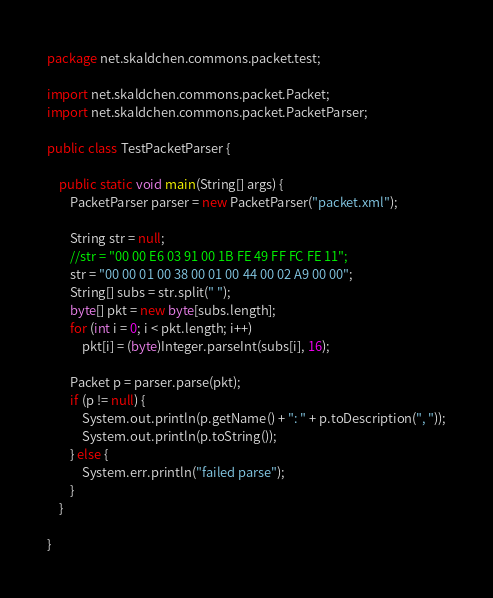<code> <loc_0><loc_0><loc_500><loc_500><_Java_>package net.skaldchen.commons.packet.test;

import net.skaldchen.commons.packet.Packet;
import net.skaldchen.commons.packet.PacketParser;

public class TestPacketParser {

    public static void main(String[] args) {
        PacketParser parser = new PacketParser("packet.xml");

        String str = null;
        //str = "00 00 E6 03 91 00 1B FE 49 FF FC FE 11";
        str = "00 00 01 00 38 00 01 00 44 00 02 A9 00 00";
        String[] subs = str.split(" ");
        byte[] pkt = new byte[subs.length];
        for (int i = 0; i < pkt.length; i++)
            pkt[i] = (byte)Integer.parseInt(subs[i], 16);

        Packet p = parser.parse(pkt);
        if (p != null) {
            System.out.println(p.getName() + ": " + p.toDescription(", "));
            System.out.println(p.toString());
        } else {
            System.err.println("failed parse");
        }
    }

}
</code> 